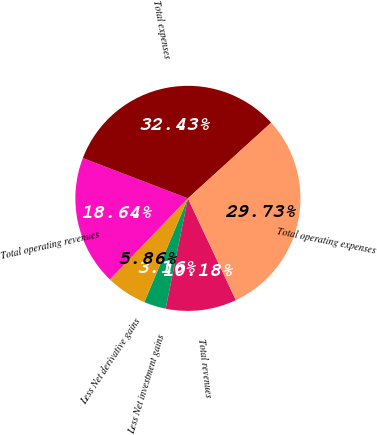Convert chart. <chart><loc_0><loc_0><loc_500><loc_500><pie_chart><fcel>Total revenues<fcel>Less Net investment gains<fcel>Less Net derivative gains<fcel>Total operating revenues<fcel>Total expenses<fcel>Total operating expenses<nl><fcel>10.18%<fcel>3.16%<fcel>5.86%<fcel>18.64%<fcel>32.43%<fcel>29.73%<nl></chart> 